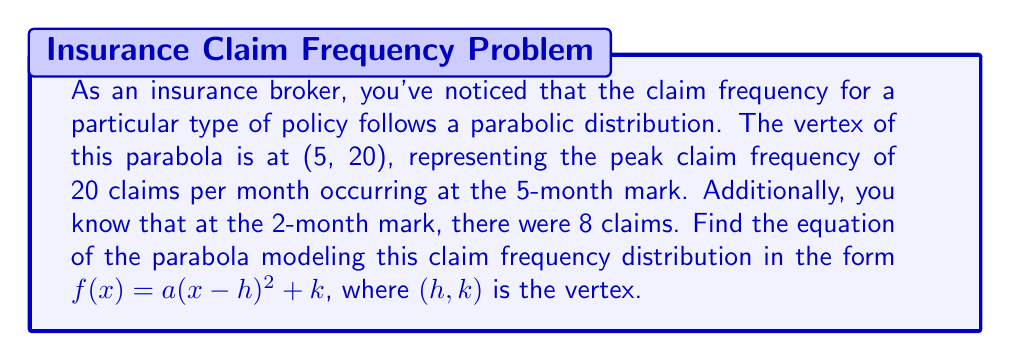What is the answer to this math problem? Let's approach this step-by-step:

1) We're given that the vertex is at (5, 20), so $h = 5$ and $k = 20$.

2) The general form of a parabola with vertex $(h,k)$ is:

   $f(x) = a(x-h)^2 + k$

3) Substituting our known values:

   $f(x) = a(x-5)^2 + 20$

4) We need to find the value of $a$. We can use the additional point given: at x = 2, f(x) = 8.

5) Let's substitute these values into our equation:

   $8 = a(2-5)^2 + 20$

6) Simplify:

   $8 = a(-3)^2 + 20$
   $8 = 9a + 20$

7) Solve for $a$:

   $-12 = 9a$
   $a = -\frac{12}{9} = -\frac{4}{3}$

8) Now we have our final equation:

   $f(x) = -\frac{4}{3}(x-5)^2 + 20$

This equation models the claim frequency distribution, where $x$ represents the month and $f(x)$ represents the number of claims.
Answer: $f(x) = -\frac{4}{3}(x-5)^2 + 20$ 